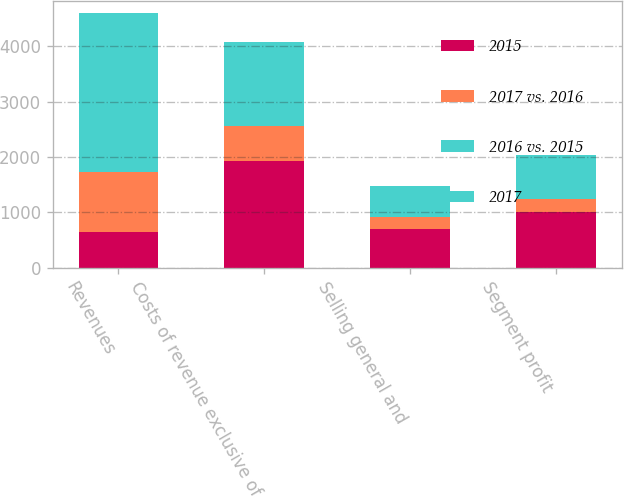Convert chart. <chart><loc_0><loc_0><loc_500><loc_500><stacked_bar_chart><ecel><fcel>Revenues<fcel>Costs of revenue exclusive of<fcel>Selling general and<fcel>Segment profit<nl><fcel>2015<fcel>641<fcel>1917<fcel>703<fcel>1010<nl><fcel>2017 vs. 2016<fcel>1089<fcel>641<fcel>214<fcel>234<nl><fcel>2016 vs. 2015<fcel>323<fcel>239<fcel>65<fcel>19<nl><fcel>2017<fcel>2541<fcel>1276<fcel>489<fcel>776<nl></chart> 